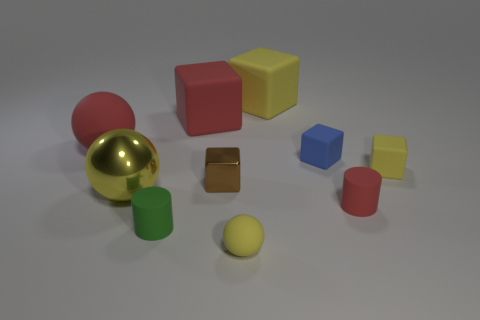Subtract all small yellow matte spheres. How many spheres are left? 2 Subtract 1 balls. How many balls are left? 2 Subtract all green cylinders. How many cylinders are left? 1 Subtract all cylinders. How many objects are left? 8 Subtract all blue blocks. Subtract all gray cylinders. How many blocks are left? 4 Subtract all red blocks. How many yellow spheres are left? 2 Subtract all big yellow metallic balls. Subtract all tiny yellow matte balls. How many objects are left? 8 Add 2 yellow rubber spheres. How many yellow rubber spheres are left? 3 Add 8 big gray rubber blocks. How many big gray rubber blocks exist? 8 Subtract 0 cyan spheres. How many objects are left? 10 